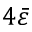Convert formula to latex. <formula><loc_0><loc_0><loc_500><loc_500>4 \bar { \varepsilon }</formula> 